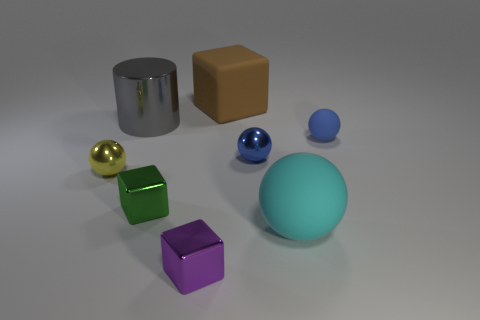Add 1 tiny metal balls. How many objects exist? 9 Subtract all cylinders. How many objects are left? 7 Subtract 0 red cylinders. How many objects are left? 8 Subtract all small gray cubes. Subtract all blue rubber spheres. How many objects are left? 7 Add 4 cyan things. How many cyan things are left? 5 Add 3 large cyan rubber cylinders. How many large cyan rubber cylinders exist? 3 